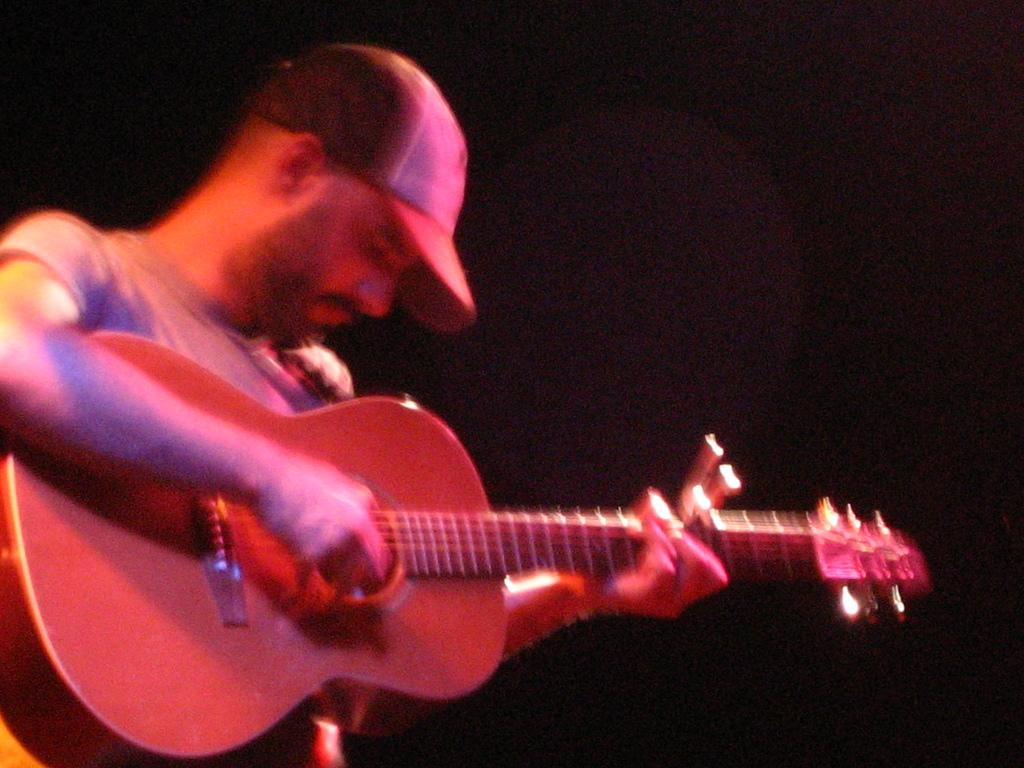What is the main subject of the image? There is a person in the image. What is the person doing in the image? The person is playing a guitar. Can you describe the person's attire in the image? The person is wearing a cap. What type of dock can be seen in the image? There is no dock present in the image. How many marbles are visible in the image? There are no marbles present in the image. 